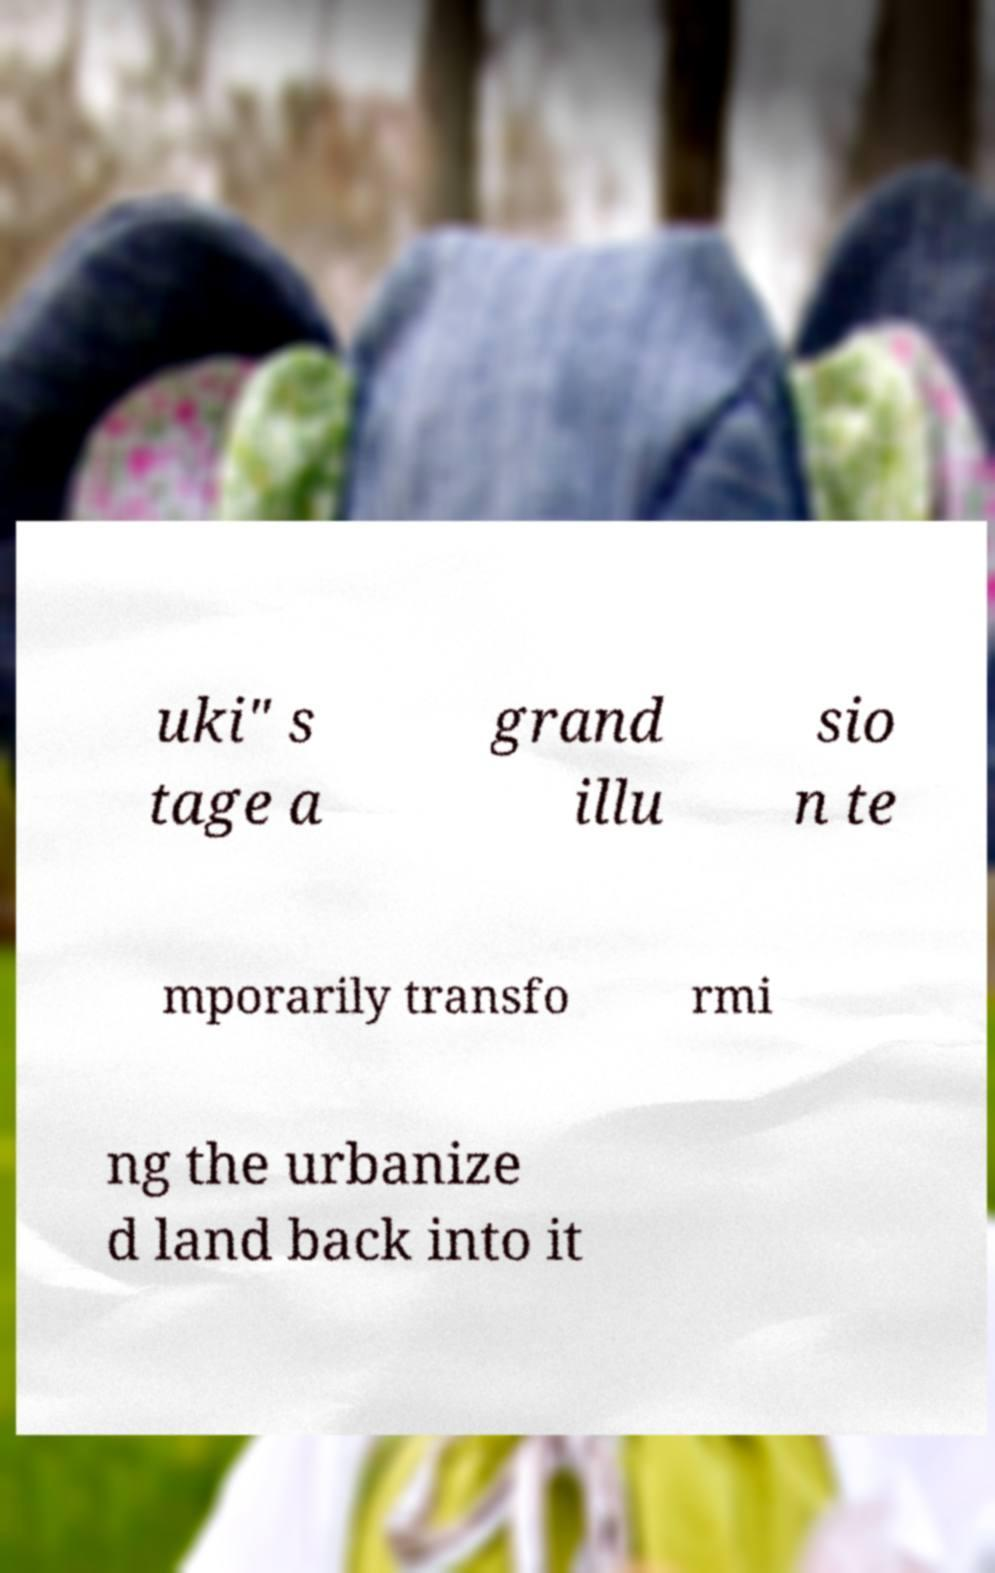Can you read and provide the text displayed in the image?This photo seems to have some interesting text. Can you extract and type it out for me? uki" s tage a grand illu sio n te mporarily transfo rmi ng the urbanize d land back into it 